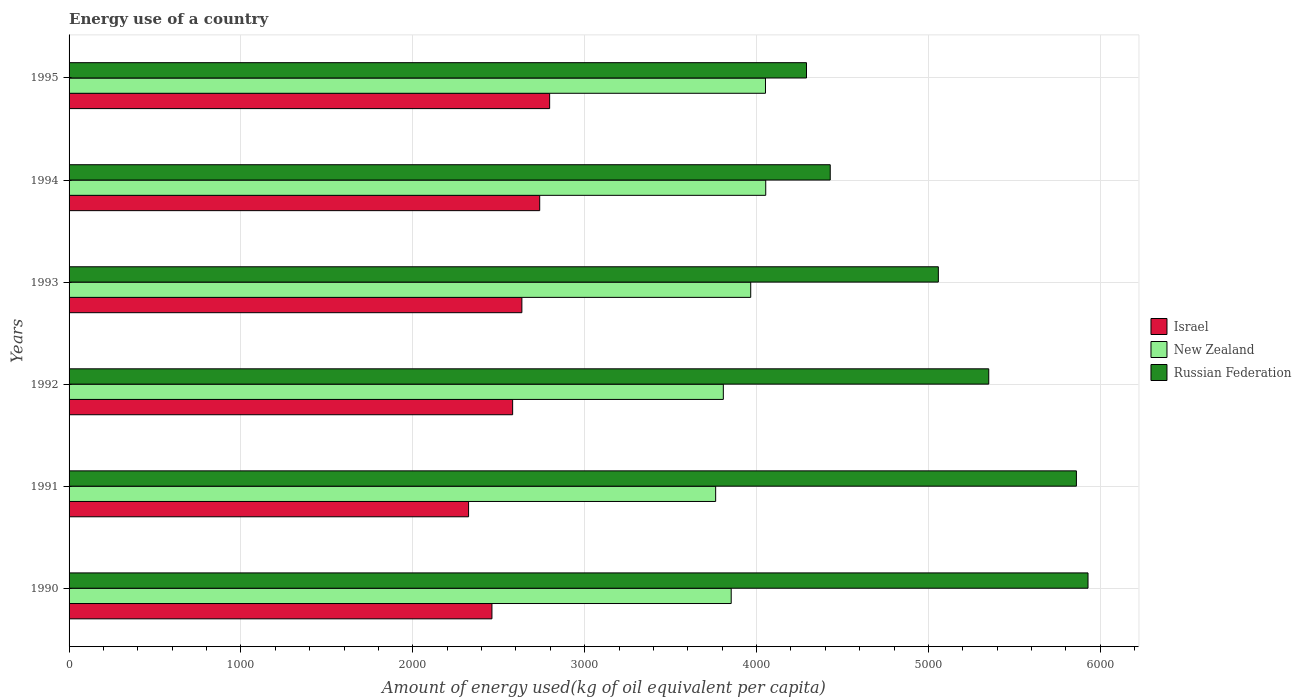How many different coloured bars are there?
Give a very brief answer. 3. Are the number of bars per tick equal to the number of legend labels?
Provide a succinct answer. Yes. Are the number of bars on each tick of the Y-axis equal?
Give a very brief answer. Yes. How many bars are there on the 4th tick from the bottom?
Provide a succinct answer. 3. What is the label of the 6th group of bars from the top?
Keep it short and to the point. 1990. In how many cases, is the number of bars for a given year not equal to the number of legend labels?
Provide a short and direct response. 0. What is the amount of energy used in in Israel in 1994?
Your answer should be compact. 2738.4. Across all years, what is the maximum amount of energy used in in New Zealand?
Make the answer very short. 4053.61. Across all years, what is the minimum amount of energy used in in New Zealand?
Your response must be concise. 3762.17. In which year was the amount of energy used in in Russian Federation maximum?
Ensure brevity in your answer.  1990. In which year was the amount of energy used in in Russian Federation minimum?
Your answer should be compact. 1995. What is the total amount of energy used in in Israel in the graph?
Offer a very short reply. 1.55e+04. What is the difference between the amount of energy used in in Russian Federation in 1991 and that in 1995?
Your answer should be compact. 1570.48. What is the difference between the amount of energy used in in Israel in 1994 and the amount of energy used in in New Zealand in 1991?
Give a very brief answer. -1023.77. What is the average amount of energy used in in Israel per year?
Make the answer very short. 2589.22. In the year 1994, what is the difference between the amount of energy used in in Israel and amount of energy used in in Russian Federation?
Give a very brief answer. -1690.49. What is the ratio of the amount of energy used in in Israel in 1992 to that in 1994?
Make the answer very short. 0.94. Is the amount of energy used in in Israel in 1990 less than that in 1991?
Your answer should be very brief. No. Is the difference between the amount of energy used in in Israel in 1994 and 1995 greater than the difference between the amount of energy used in in Russian Federation in 1994 and 1995?
Give a very brief answer. No. What is the difference between the highest and the second highest amount of energy used in in Israel?
Provide a succinct answer. 57.85. What is the difference between the highest and the lowest amount of energy used in in New Zealand?
Ensure brevity in your answer.  291.44. What does the 2nd bar from the top in 1992 represents?
Ensure brevity in your answer.  New Zealand. What does the 3rd bar from the bottom in 1993 represents?
Your response must be concise. Russian Federation. How many bars are there?
Your answer should be compact. 18. What is the difference between two consecutive major ticks on the X-axis?
Ensure brevity in your answer.  1000. Are the values on the major ticks of X-axis written in scientific E-notation?
Keep it short and to the point. No. Where does the legend appear in the graph?
Your response must be concise. Center right. What is the title of the graph?
Ensure brevity in your answer.  Energy use of a country. What is the label or title of the X-axis?
Provide a short and direct response. Amount of energy used(kg of oil equivalent per capita). What is the label or title of the Y-axis?
Keep it short and to the point. Years. What is the Amount of energy used(kg of oil equivalent per capita) in Israel in 1990?
Ensure brevity in your answer.  2460.47. What is the Amount of energy used(kg of oil equivalent per capita) in New Zealand in 1990?
Give a very brief answer. 3852.64. What is the Amount of energy used(kg of oil equivalent per capita) in Russian Federation in 1990?
Give a very brief answer. 5928.79. What is the Amount of energy used(kg of oil equivalent per capita) in Israel in 1991?
Ensure brevity in your answer.  2324.54. What is the Amount of energy used(kg of oil equivalent per capita) in New Zealand in 1991?
Your answer should be very brief. 3762.17. What is the Amount of energy used(kg of oil equivalent per capita) of Russian Federation in 1991?
Your answer should be very brief. 5861.25. What is the Amount of energy used(kg of oil equivalent per capita) in Israel in 1992?
Your answer should be compact. 2580.97. What is the Amount of energy used(kg of oil equivalent per capita) of New Zealand in 1992?
Your answer should be compact. 3806.85. What is the Amount of energy used(kg of oil equivalent per capita) in Russian Federation in 1992?
Provide a short and direct response. 5351.22. What is the Amount of energy used(kg of oil equivalent per capita) in Israel in 1993?
Make the answer very short. 2634.67. What is the Amount of energy used(kg of oil equivalent per capita) of New Zealand in 1993?
Your answer should be compact. 3966.26. What is the Amount of energy used(kg of oil equivalent per capita) in Russian Federation in 1993?
Provide a short and direct response. 5057.92. What is the Amount of energy used(kg of oil equivalent per capita) of Israel in 1994?
Offer a very short reply. 2738.4. What is the Amount of energy used(kg of oil equivalent per capita) of New Zealand in 1994?
Offer a very short reply. 4053.61. What is the Amount of energy used(kg of oil equivalent per capita) of Russian Federation in 1994?
Your answer should be very brief. 4428.89. What is the Amount of energy used(kg of oil equivalent per capita) of Israel in 1995?
Your answer should be very brief. 2796.25. What is the Amount of energy used(kg of oil equivalent per capita) of New Zealand in 1995?
Your answer should be compact. 4052.12. What is the Amount of energy used(kg of oil equivalent per capita) of Russian Federation in 1995?
Provide a short and direct response. 4290.77. Across all years, what is the maximum Amount of energy used(kg of oil equivalent per capita) in Israel?
Provide a succinct answer. 2796.25. Across all years, what is the maximum Amount of energy used(kg of oil equivalent per capita) in New Zealand?
Your answer should be very brief. 4053.61. Across all years, what is the maximum Amount of energy used(kg of oil equivalent per capita) in Russian Federation?
Your answer should be compact. 5928.79. Across all years, what is the minimum Amount of energy used(kg of oil equivalent per capita) in Israel?
Your response must be concise. 2324.54. Across all years, what is the minimum Amount of energy used(kg of oil equivalent per capita) in New Zealand?
Provide a succinct answer. 3762.17. Across all years, what is the minimum Amount of energy used(kg of oil equivalent per capita) of Russian Federation?
Give a very brief answer. 4290.77. What is the total Amount of energy used(kg of oil equivalent per capita) of Israel in the graph?
Offer a very short reply. 1.55e+04. What is the total Amount of energy used(kg of oil equivalent per capita) in New Zealand in the graph?
Give a very brief answer. 2.35e+04. What is the total Amount of energy used(kg of oil equivalent per capita) of Russian Federation in the graph?
Give a very brief answer. 3.09e+04. What is the difference between the Amount of energy used(kg of oil equivalent per capita) in Israel in 1990 and that in 1991?
Offer a very short reply. 135.93. What is the difference between the Amount of energy used(kg of oil equivalent per capita) of New Zealand in 1990 and that in 1991?
Ensure brevity in your answer.  90.47. What is the difference between the Amount of energy used(kg of oil equivalent per capita) of Russian Federation in 1990 and that in 1991?
Provide a short and direct response. 67.54. What is the difference between the Amount of energy used(kg of oil equivalent per capita) of Israel in 1990 and that in 1992?
Your response must be concise. -120.5. What is the difference between the Amount of energy used(kg of oil equivalent per capita) of New Zealand in 1990 and that in 1992?
Your answer should be very brief. 45.79. What is the difference between the Amount of energy used(kg of oil equivalent per capita) of Russian Federation in 1990 and that in 1992?
Your answer should be very brief. 577.58. What is the difference between the Amount of energy used(kg of oil equivalent per capita) in Israel in 1990 and that in 1993?
Offer a terse response. -174.21. What is the difference between the Amount of energy used(kg of oil equivalent per capita) in New Zealand in 1990 and that in 1993?
Your response must be concise. -113.62. What is the difference between the Amount of energy used(kg of oil equivalent per capita) in Russian Federation in 1990 and that in 1993?
Provide a short and direct response. 870.87. What is the difference between the Amount of energy used(kg of oil equivalent per capita) in Israel in 1990 and that in 1994?
Provide a succinct answer. -277.93. What is the difference between the Amount of energy used(kg of oil equivalent per capita) in New Zealand in 1990 and that in 1994?
Provide a succinct answer. -200.97. What is the difference between the Amount of energy used(kg of oil equivalent per capita) of Russian Federation in 1990 and that in 1994?
Give a very brief answer. 1499.9. What is the difference between the Amount of energy used(kg of oil equivalent per capita) in Israel in 1990 and that in 1995?
Your response must be concise. -335.79. What is the difference between the Amount of energy used(kg of oil equivalent per capita) in New Zealand in 1990 and that in 1995?
Keep it short and to the point. -199.49. What is the difference between the Amount of energy used(kg of oil equivalent per capita) of Russian Federation in 1990 and that in 1995?
Offer a very short reply. 1638.02. What is the difference between the Amount of energy used(kg of oil equivalent per capita) in Israel in 1991 and that in 1992?
Your response must be concise. -256.43. What is the difference between the Amount of energy used(kg of oil equivalent per capita) of New Zealand in 1991 and that in 1992?
Keep it short and to the point. -44.68. What is the difference between the Amount of energy used(kg of oil equivalent per capita) of Russian Federation in 1991 and that in 1992?
Give a very brief answer. 510.03. What is the difference between the Amount of energy used(kg of oil equivalent per capita) in Israel in 1991 and that in 1993?
Your answer should be very brief. -310.13. What is the difference between the Amount of energy used(kg of oil equivalent per capita) in New Zealand in 1991 and that in 1993?
Your answer should be very brief. -204.09. What is the difference between the Amount of energy used(kg of oil equivalent per capita) in Russian Federation in 1991 and that in 1993?
Keep it short and to the point. 803.33. What is the difference between the Amount of energy used(kg of oil equivalent per capita) of Israel in 1991 and that in 1994?
Provide a short and direct response. -413.86. What is the difference between the Amount of energy used(kg of oil equivalent per capita) of New Zealand in 1991 and that in 1994?
Your response must be concise. -291.44. What is the difference between the Amount of energy used(kg of oil equivalent per capita) in Russian Federation in 1991 and that in 1994?
Provide a short and direct response. 1432.36. What is the difference between the Amount of energy used(kg of oil equivalent per capita) in Israel in 1991 and that in 1995?
Your answer should be compact. -471.71. What is the difference between the Amount of energy used(kg of oil equivalent per capita) in New Zealand in 1991 and that in 1995?
Offer a terse response. -289.96. What is the difference between the Amount of energy used(kg of oil equivalent per capita) of Russian Federation in 1991 and that in 1995?
Your answer should be very brief. 1570.48. What is the difference between the Amount of energy used(kg of oil equivalent per capita) of Israel in 1992 and that in 1993?
Offer a terse response. -53.7. What is the difference between the Amount of energy used(kg of oil equivalent per capita) of New Zealand in 1992 and that in 1993?
Ensure brevity in your answer.  -159.41. What is the difference between the Amount of energy used(kg of oil equivalent per capita) in Russian Federation in 1992 and that in 1993?
Offer a very short reply. 293.3. What is the difference between the Amount of energy used(kg of oil equivalent per capita) of Israel in 1992 and that in 1994?
Ensure brevity in your answer.  -157.43. What is the difference between the Amount of energy used(kg of oil equivalent per capita) in New Zealand in 1992 and that in 1994?
Give a very brief answer. -246.76. What is the difference between the Amount of energy used(kg of oil equivalent per capita) of Russian Federation in 1992 and that in 1994?
Offer a very short reply. 922.33. What is the difference between the Amount of energy used(kg of oil equivalent per capita) of Israel in 1992 and that in 1995?
Your answer should be very brief. -215.28. What is the difference between the Amount of energy used(kg of oil equivalent per capita) of New Zealand in 1992 and that in 1995?
Your answer should be very brief. -245.28. What is the difference between the Amount of energy used(kg of oil equivalent per capita) in Russian Federation in 1992 and that in 1995?
Your answer should be very brief. 1060.44. What is the difference between the Amount of energy used(kg of oil equivalent per capita) of Israel in 1993 and that in 1994?
Give a very brief answer. -103.73. What is the difference between the Amount of energy used(kg of oil equivalent per capita) in New Zealand in 1993 and that in 1994?
Keep it short and to the point. -87.35. What is the difference between the Amount of energy used(kg of oil equivalent per capita) of Russian Federation in 1993 and that in 1994?
Provide a short and direct response. 629.03. What is the difference between the Amount of energy used(kg of oil equivalent per capita) in Israel in 1993 and that in 1995?
Your answer should be compact. -161.58. What is the difference between the Amount of energy used(kg of oil equivalent per capita) in New Zealand in 1993 and that in 1995?
Provide a short and direct response. -85.86. What is the difference between the Amount of energy used(kg of oil equivalent per capita) of Russian Federation in 1993 and that in 1995?
Provide a short and direct response. 767.15. What is the difference between the Amount of energy used(kg of oil equivalent per capita) of Israel in 1994 and that in 1995?
Ensure brevity in your answer.  -57.85. What is the difference between the Amount of energy used(kg of oil equivalent per capita) in New Zealand in 1994 and that in 1995?
Ensure brevity in your answer.  1.49. What is the difference between the Amount of energy used(kg of oil equivalent per capita) in Russian Federation in 1994 and that in 1995?
Provide a succinct answer. 138.12. What is the difference between the Amount of energy used(kg of oil equivalent per capita) of Israel in 1990 and the Amount of energy used(kg of oil equivalent per capita) of New Zealand in 1991?
Keep it short and to the point. -1301.7. What is the difference between the Amount of energy used(kg of oil equivalent per capita) in Israel in 1990 and the Amount of energy used(kg of oil equivalent per capita) in Russian Federation in 1991?
Ensure brevity in your answer.  -3400.78. What is the difference between the Amount of energy used(kg of oil equivalent per capita) in New Zealand in 1990 and the Amount of energy used(kg of oil equivalent per capita) in Russian Federation in 1991?
Your answer should be compact. -2008.61. What is the difference between the Amount of energy used(kg of oil equivalent per capita) in Israel in 1990 and the Amount of energy used(kg of oil equivalent per capita) in New Zealand in 1992?
Offer a terse response. -1346.38. What is the difference between the Amount of energy used(kg of oil equivalent per capita) in Israel in 1990 and the Amount of energy used(kg of oil equivalent per capita) in Russian Federation in 1992?
Provide a succinct answer. -2890.75. What is the difference between the Amount of energy used(kg of oil equivalent per capita) of New Zealand in 1990 and the Amount of energy used(kg of oil equivalent per capita) of Russian Federation in 1992?
Ensure brevity in your answer.  -1498.58. What is the difference between the Amount of energy used(kg of oil equivalent per capita) of Israel in 1990 and the Amount of energy used(kg of oil equivalent per capita) of New Zealand in 1993?
Your response must be concise. -1505.79. What is the difference between the Amount of energy used(kg of oil equivalent per capita) in Israel in 1990 and the Amount of energy used(kg of oil equivalent per capita) in Russian Federation in 1993?
Your response must be concise. -2597.45. What is the difference between the Amount of energy used(kg of oil equivalent per capita) in New Zealand in 1990 and the Amount of energy used(kg of oil equivalent per capita) in Russian Federation in 1993?
Provide a succinct answer. -1205.28. What is the difference between the Amount of energy used(kg of oil equivalent per capita) of Israel in 1990 and the Amount of energy used(kg of oil equivalent per capita) of New Zealand in 1994?
Provide a succinct answer. -1593.14. What is the difference between the Amount of energy used(kg of oil equivalent per capita) in Israel in 1990 and the Amount of energy used(kg of oil equivalent per capita) in Russian Federation in 1994?
Your answer should be compact. -1968.42. What is the difference between the Amount of energy used(kg of oil equivalent per capita) in New Zealand in 1990 and the Amount of energy used(kg of oil equivalent per capita) in Russian Federation in 1994?
Offer a very short reply. -576.25. What is the difference between the Amount of energy used(kg of oil equivalent per capita) in Israel in 1990 and the Amount of energy used(kg of oil equivalent per capita) in New Zealand in 1995?
Offer a terse response. -1591.66. What is the difference between the Amount of energy used(kg of oil equivalent per capita) of Israel in 1990 and the Amount of energy used(kg of oil equivalent per capita) of Russian Federation in 1995?
Ensure brevity in your answer.  -1830.31. What is the difference between the Amount of energy used(kg of oil equivalent per capita) in New Zealand in 1990 and the Amount of energy used(kg of oil equivalent per capita) in Russian Federation in 1995?
Offer a terse response. -438.14. What is the difference between the Amount of energy used(kg of oil equivalent per capita) in Israel in 1991 and the Amount of energy used(kg of oil equivalent per capita) in New Zealand in 1992?
Your response must be concise. -1482.31. What is the difference between the Amount of energy used(kg of oil equivalent per capita) of Israel in 1991 and the Amount of energy used(kg of oil equivalent per capita) of Russian Federation in 1992?
Your response must be concise. -3026.68. What is the difference between the Amount of energy used(kg of oil equivalent per capita) of New Zealand in 1991 and the Amount of energy used(kg of oil equivalent per capita) of Russian Federation in 1992?
Make the answer very short. -1589.05. What is the difference between the Amount of energy used(kg of oil equivalent per capita) in Israel in 1991 and the Amount of energy used(kg of oil equivalent per capita) in New Zealand in 1993?
Keep it short and to the point. -1641.72. What is the difference between the Amount of energy used(kg of oil equivalent per capita) of Israel in 1991 and the Amount of energy used(kg of oil equivalent per capita) of Russian Federation in 1993?
Your answer should be very brief. -2733.38. What is the difference between the Amount of energy used(kg of oil equivalent per capita) of New Zealand in 1991 and the Amount of energy used(kg of oil equivalent per capita) of Russian Federation in 1993?
Your response must be concise. -1295.75. What is the difference between the Amount of energy used(kg of oil equivalent per capita) in Israel in 1991 and the Amount of energy used(kg of oil equivalent per capita) in New Zealand in 1994?
Give a very brief answer. -1729.07. What is the difference between the Amount of energy used(kg of oil equivalent per capita) of Israel in 1991 and the Amount of energy used(kg of oil equivalent per capita) of Russian Federation in 1994?
Provide a short and direct response. -2104.35. What is the difference between the Amount of energy used(kg of oil equivalent per capita) in New Zealand in 1991 and the Amount of energy used(kg of oil equivalent per capita) in Russian Federation in 1994?
Your response must be concise. -666.72. What is the difference between the Amount of energy used(kg of oil equivalent per capita) in Israel in 1991 and the Amount of energy used(kg of oil equivalent per capita) in New Zealand in 1995?
Your answer should be very brief. -1727.58. What is the difference between the Amount of energy used(kg of oil equivalent per capita) in Israel in 1991 and the Amount of energy used(kg of oil equivalent per capita) in Russian Federation in 1995?
Ensure brevity in your answer.  -1966.23. What is the difference between the Amount of energy used(kg of oil equivalent per capita) in New Zealand in 1991 and the Amount of energy used(kg of oil equivalent per capita) in Russian Federation in 1995?
Make the answer very short. -528.61. What is the difference between the Amount of energy used(kg of oil equivalent per capita) of Israel in 1992 and the Amount of energy used(kg of oil equivalent per capita) of New Zealand in 1993?
Offer a very short reply. -1385.29. What is the difference between the Amount of energy used(kg of oil equivalent per capita) of Israel in 1992 and the Amount of energy used(kg of oil equivalent per capita) of Russian Federation in 1993?
Make the answer very short. -2476.95. What is the difference between the Amount of energy used(kg of oil equivalent per capita) of New Zealand in 1992 and the Amount of energy used(kg of oil equivalent per capita) of Russian Federation in 1993?
Offer a very short reply. -1251.07. What is the difference between the Amount of energy used(kg of oil equivalent per capita) of Israel in 1992 and the Amount of energy used(kg of oil equivalent per capita) of New Zealand in 1994?
Your response must be concise. -1472.64. What is the difference between the Amount of energy used(kg of oil equivalent per capita) of Israel in 1992 and the Amount of energy used(kg of oil equivalent per capita) of Russian Federation in 1994?
Your response must be concise. -1847.92. What is the difference between the Amount of energy used(kg of oil equivalent per capita) of New Zealand in 1992 and the Amount of energy used(kg of oil equivalent per capita) of Russian Federation in 1994?
Your answer should be very brief. -622.04. What is the difference between the Amount of energy used(kg of oil equivalent per capita) of Israel in 1992 and the Amount of energy used(kg of oil equivalent per capita) of New Zealand in 1995?
Make the answer very short. -1471.15. What is the difference between the Amount of energy used(kg of oil equivalent per capita) in Israel in 1992 and the Amount of energy used(kg of oil equivalent per capita) in Russian Federation in 1995?
Provide a short and direct response. -1709.8. What is the difference between the Amount of energy used(kg of oil equivalent per capita) of New Zealand in 1992 and the Amount of energy used(kg of oil equivalent per capita) of Russian Federation in 1995?
Provide a short and direct response. -483.93. What is the difference between the Amount of energy used(kg of oil equivalent per capita) of Israel in 1993 and the Amount of energy used(kg of oil equivalent per capita) of New Zealand in 1994?
Your answer should be compact. -1418.93. What is the difference between the Amount of energy used(kg of oil equivalent per capita) in Israel in 1993 and the Amount of energy used(kg of oil equivalent per capita) in Russian Federation in 1994?
Your answer should be very brief. -1794.22. What is the difference between the Amount of energy used(kg of oil equivalent per capita) in New Zealand in 1993 and the Amount of energy used(kg of oil equivalent per capita) in Russian Federation in 1994?
Offer a terse response. -462.63. What is the difference between the Amount of energy used(kg of oil equivalent per capita) of Israel in 1993 and the Amount of energy used(kg of oil equivalent per capita) of New Zealand in 1995?
Ensure brevity in your answer.  -1417.45. What is the difference between the Amount of energy used(kg of oil equivalent per capita) in Israel in 1993 and the Amount of energy used(kg of oil equivalent per capita) in Russian Federation in 1995?
Give a very brief answer. -1656.1. What is the difference between the Amount of energy used(kg of oil equivalent per capita) in New Zealand in 1993 and the Amount of energy used(kg of oil equivalent per capita) in Russian Federation in 1995?
Provide a short and direct response. -324.51. What is the difference between the Amount of energy used(kg of oil equivalent per capita) of Israel in 1994 and the Amount of energy used(kg of oil equivalent per capita) of New Zealand in 1995?
Provide a short and direct response. -1313.72. What is the difference between the Amount of energy used(kg of oil equivalent per capita) in Israel in 1994 and the Amount of energy used(kg of oil equivalent per capita) in Russian Federation in 1995?
Your answer should be very brief. -1552.37. What is the difference between the Amount of energy used(kg of oil equivalent per capita) in New Zealand in 1994 and the Amount of energy used(kg of oil equivalent per capita) in Russian Federation in 1995?
Offer a very short reply. -237.16. What is the average Amount of energy used(kg of oil equivalent per capita) of Israel per year?
Provide a succinct answer. 2589.22. What is the average Amount of energy used(kg of oil equivalent per capita) of New Zealand per year?
Provide a short and direct response. 3915.61. What is the average Amount of energy used(kg of oil equivalent per capita) of Russian Federation per year?
Provide a succinct answer. 5153.14. In the year 1990, what is the difference between the Amount of energy used(kg of oil equivalent per capita) in Israel and Amount of energy used(kg of oil equivalent per capita) in New Zealand?
Give a very brief answer. -1392.17. In the year 1990, what is the difference between the Amount of energy used(kg of oil equivalent per capita) of Israel and Amount of energy used(kg of oil equivalent per capita) of Russian Federation?
Your answer should be very brief. -3468.33. In the year 1990, what is the difference between the Amount of energy used(kg of oil equivalent per capita) of New Zealand and Amount of energy used(kg of oil equivalent per capita) of Russian Federation?
Offer a terse response. -2076.16. In the year 1991, what is the difference between the Amount of energy used(kg of oil equivalent per capita) of Israel and Amount of energy used(kg of oil equivalent per capita) of New Zealand?
Keep it short and to the point. -1437.63. In the year 1991, what is the difference between the Amount of energy used(kg of oil equivalent per capita) in Israel and Amount of energy used(kg of oil equivalent per capita) in Russian Federation?
Your answer should be very brief. -3536.71. In the year 1991, what is the difference between the Amount of energy used(kg of oil equivalent per capita) of New Zealand and Amount of energy used(kg of oil equivalent per capita) of Russian Federation?
Your response must be concise. -2099.08. In the year 1992, what is the difference between the Amount of energy used(kg of oil equivalent per capita) of Israel and Amount of energy used(kg of oil equivalent per capita) of New Zealand?
Provide a succinct answer. -1225.88. In the year 1992, what is the difference between the Amount of energy used(kg of oil equivalent per capita) of Israel and Amount of energy used(kg of oil equivalent per capita) of Russian Federation?
Provide a short and direct response. -2770.25. In the year 1992, what is the difference between the Amount of energy used(kg of oil equivalent per capita) of New Zealand and Amount of energy used(kg of oil equivalent per capita) of Russian Federation?
Provide a succinct answer. -1544.37. In the year 1993, what is the difference between the Amount of energy used(kg of oil equivalent per capita) in Israel and Amount of energy used(kg of oil equivalent per capita) in New Zealand?
Your answer should be compact. -1331.58. In the year 1993, what is the difference between the Amount of energy used(kg of oil equivalent per capita) of Israel and Amount of energy used(kg of oil equivalent per capita) of Russian Federation?
Your answer should be very brief. -2423.25. In the year 1993, what is the difference between the Amount of energy used(kg of oil equivalent per capita) of New Zealand and Amount of energy used(kg of oil equivalent per capita) of Russian Federation?
Offer a terse response. -1091.66. In the year 1994, what is the difference between the Amount of energy used(kg of oil equivalent per capita) in Israel and Amount of energy used(kg of oil equivalent per capita) in New Zealand?
Your answer should be very brief. -1315.21. In the year 1994, what is the difference between the Amount of energy used(kg of oil equivalent per capita) in Israel and Amount of energy used(kg of oil equivalent per capita) in Russian Federation?
Offer a very short reply. -1690.49. In the year 1994, what is the difference between the Amount of energy used(kg of oil equivalent per capita) of New Zealand and Amount of energy used(kg of oil equivalent per capita) of Russian Federation?
Offer a very short reply. -375.28. In the year 1995, what is the difference between the Amount of energy used(kg of oil equivalent per capita) of Israel and Amount of energy used(kg of oil equivalent per capita) of New Zealand?
Keep it short and to the point. -1255.87. In the year 1995, what is the difference between the Amount of energy used(kg of oil equivalent per capita) of Israel and Amount of energy used(kg of oil equivalent per capita) of Russian Federation?
Offer a terse response. -1494.52. In the year 1995, what is the difference between the Amount of energy used(kg of oil equivalent per capita) of New Zealand and Amount of energy used(kg of oil equivalent per capita) of Russian Federation?
Your response must be concise. -238.65. What is the ratio of the Amount of energy used(kg of oil equivalent per capita) of Israel in 1990 to that in 1991?
Your answer should be compact. 1.06. What is the ratio of the Amount of energy used(kg of oil equivalent per capita) of New Zealand in 1990 to that in 1991?
Offer a terse response. 1.02. What is the ratio of the Amount of energy used(kg of oil equivalent per capita) in Russian Federation in 1990 to that in 1991?
Make the answer very short. 1.01. What is the ratio of the Amount of energy used(kg of oil equivalent per capita) of Israel in 1990 to that in 1992?
Your response must be concise. 0.95. What is the ratio of the Amount of energy used(kg of oil equivalent per capita) of Russian Federation in 1990 to that in 1992?
Your response must be concise. 1.11. What is the ratio of the Amount of energy used(kg of oil equivalent per capita) of Israel in 1990 to that in 1993?
Ensure brevity in your answer.  0.93. What is the ratio of the Amount of energy used(kg of oil equivalent per capita) of New Zealand in 1990 to that in 1993?
Offer a terse response. 0.97. What is the ratio of the Amount of energy used(kg of oil equivalent per capita) in Russian Federation in 1990 to that in 1993?
Your answer should be very brief. 1.17. What is the ratio of the Amount of energy used(kg of oil equivalent per capita) of Israel in 1990 to that in 1994?
Offer a terse response. 0.9. What is the ratio of the Amount of energy used(kg of oil equivalent per capita) of New Zealand in 1990 to that in 1994?
Ensure brevity in your answer.  0.95. What is the ratio of the Amount of energy used(kg of oil equivalent per capita) of Russian Federation in 1990 to that in 1994?
Provide a short and direct response. 1.34. What is the ratio of the Amount of energy used(kg of oil equivalent per capita) in Israel in 1990 to that in 1995?
Provide a succinct answer. 0.88. What is the ratio of the Amount of energy used(kg of oil equivalent per capita) of New Zealand in 1990 to that in 1995?
Ensure brevity in your answer.  0.95. What is the ratio of the Amount of energy used(kg of oil equivalent per capita) of Russian Federation in 1990 to that in 1995?
Offer a very short reply. 1.38. What is the ratio of the Amount of energy used(kg of oil equivalent per capita) of Israel in 1991 to that in 1992?
Your response must be concise. 0.9. What is the ratio of the Amount of energy used(kg of oil equivalent per capita) in New Zealand in 1991 to that in 1992?
Provide a short and direct response. 0.99. What is the ratio of the Amount of energy used(kg of oil equivalent per capita) in Russian Federation in 1991 to that in 1992?
Offer a very short reply. 1.1. What is the ratio of the Amount of energy used(kg of oil equivalent per capita) in Israel in 1991 to that in 1993?
Provide a short and direct response. 0.88. What is the ratio of the Amount of energy used(kg of oil equivalent per capita) of New Zealand in 1991 to that in 1993?
Make the answer very short. 0.95. What is the ratio of the Amount of energy used(kg of oil equivalent per capita) in Russian Federation in 1991 to that in 1993?
Provide a short and direct response. 1.16. What is the ratio of the Amount of energy used(kg of oil equivalent per capita) in Israel in 1991 to that in 1994?
Give a very brief answer. 0.85. What is the ratio of the Amount of energy used(kg of oil equivalent per capita) in New Zealand in 1991 to that in 1994?
Your response must be concise. 0.93. What is the ratio of the Amount of energy used(kg of oil equivalent per capita) of Russian Federation in 1991 to that in 1994?
Provide a short and direct response. 1.32. What is the ratio of the Amount of energy used(kg of oil equivalent per capita) in Israel in 1991 to that in 1995?
Your answer should be compact. 0.83. What is the ratio of the Amount of energy used(kg of oil equivalent per capita) in New Zealand in 1991 to that in 1995?
Your response must be concise. 0.93. What is the ratio of the Amount of energy used(kg of oil equivalent per capita) in Russian Federation in 1991 to that in 1995?
Offer a terse response. 1.37. What is the ratio of the Amount of energy used(kg of oil equivalent per capita) in Israel in 1992 to that in 1993?
Keep it short and to the point. 0.98. What is the ratio of the Amount of energy used(kg of oil equivalent per capita) in New Zealand in 1992 to that in 1993?
Keep it short and to the point. 0.96. What is the ratio of the Amount of energy used(kg of oil equivalent per capita) in Russian Federation in 1992 to that in 1993?
Ensure brevity in your answer.  1.06. What is the ratio of the Amount of energy used(kg of oil equivalent per capita) of Israel in 1992 to that in 1994?
Provide a succinct answer. 0.94. What is the ratio of the Amount of energy used(kg of oil equivalent per capita) in New Zealand in 1992 to that in 1994?
Provide a short and direct response. 0.94. What is the ratio of the Amount of energy used(kg of oil equivalent per capita) in Russian Federation in 1992 to that in 1994?
Offer a very short reply. 1.21. What is the ratio of the Amount of energy used(kg of oil equivalent per capita) of Israel in 1992 to that in 1995?
Offer a very short reply. 0.92. What is the ratio of the Amount of energy used(kg of oil equivalent per capita) of New Zealand in 1992 to that in 1995?
Offer a terse response. 0.94. What is the ratio of the Amount of energy used(kg of oil equivalent per capita) in Russian Federation in 1992 to that in 1995?
Your answer should be compact. 1.25. What is the ratio of the Amount of energy used(kg of oil equivalent per capita) of Israel in 1993 to that in 1994?
Provide a short and direct response. 0.96. What is the ratio of the Amount of energy used(kg of oil equivalent per capita) in New Zealand in 1993 to that in 1994?
Your answer should be very brief. 0.98. What is the ratio of the Amount of energy used(kg of oil equivalent per capita) in Russian Federation in 1993 to that in 1994?
Provide a succinct answer. 1.14. What is the ratio of the Amount of energy used(kg of oil equivalent per capita) in Israel in 1993 to that in 1995?
Offer a very short reply. 0.94. What is the ratio of the Amount of energy used(kg of oil equivalent per capita) of New Zealand in 1993 to that in 1995?
Offer a terse response. 0.98. What is the ratio of the Amount of energy used(kg of oil equivalent per capita) in Russian Federation in 1993 to that in 1995?
Provide a succinct answer. 1.18. What is the ratio of the Amount of energy used(kg of oil equivalent per capita) of Israel in 1994 to that in 1995?
Offer a terse response. 0.98. What is the ratio of the Amount of energy used(kg of oil equivalent per capita) of New Zealand in 1994 to that in 1995?
Keep it short and to the point. 1. What is the ratio of the Amount of energy used(kg of oil equivalent per capita) of Russian Federation in 1994 to that in 1995?
Offer a terse response. 1.03. What is the difference between the highest and the second highest Amount of energy used(kg of oil equivalent per capita) of Israel?
Your response must be concise. 57.85. What is the difference between the highest and the second highest Amount of energy used(kg of oil equivalent per capita) of New Zealand?
Provide a succinct answer. 1.49. What is the difference between the highest and the second highest Amount of energy used(kg of oil equivalent per capita) of Russian Federation?
Offer a very short reply. 67.54. What is the difference between the highest and the lowest Amount of energy used(kg of oil equivalent per capita) of Israel?
Your response must be concise. 471.71. What is the difference between the highest and the lowest Amount of energy used(kg of oil equivalent per capita) in New Zealand?
Your answer should be very brief. 291.44. What is the difference between the highest and the lowest Amount of energy used(kg of oil equivalent per capita) of Russian Federation?
Give a very brief answer. 1638.02. 